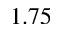<formula> <loc_0><loc_0><loc_500><loc_500>1 . 7 5</formula> 